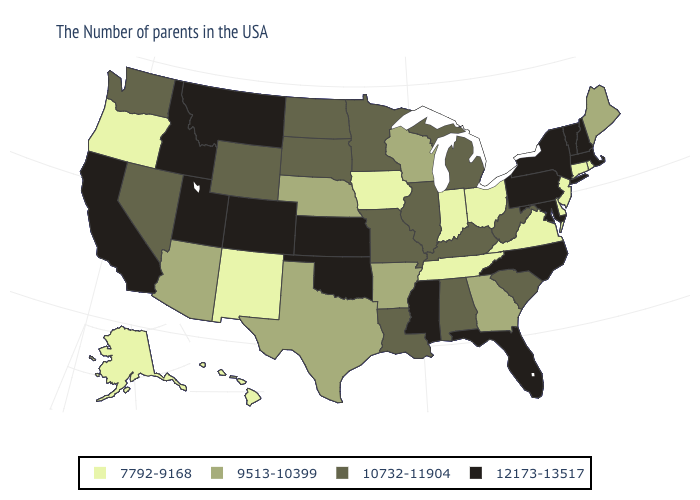What is the lowest value in states that border Oregon?
Answer briefly. 10732-11904. What is the value of Arizona?
Answer briefly. 9513-10399. Is the legend a continuous bar?
Keep it brief. No. Does Washington have the same value as Alaska?
Be succinct. No. Name the states that have a value in the range 10732-11904?
Short answer required. South Carolina, West Virginia, Michigan, Kentucky, Alabama, Illinois, Louisiana, Missouri, Minnesota, South Dakota, North Dakota, Wyoming, Nevada, Washington. Among the states that border New Mexico , does Utah have the highest value?
Write a very short answer. Yes. Name the states that have a value in the range 9513-10399?
Be succinct. Maine, Georgia, Wisconsin, Arkansas, Nebraska, Texas, Arizona. What is the value of Mississippi?
Quick response, please. 12173-13517. Name the states that have a value in the range 9513-10399?
Quick response, please. Maine, Georgia, Wisconsin, Arkansas, Nebraska, Texas, Arizona. Does New Hampshire have the same value as North Dakota?
Quick response, please. No. Name the states that have a value in the range 9513-10399?
Concise answer only. Maine, Georgia, Wisconsin, Arkansas, Nebraska, Texas, Arizona. What is the value of Massachusetts?
Keep it brief. 12173-13517. Which states hav the highest value in the MidWest?
Concise answer only. Kansas. What is the value of Oklahoma?
Short answer required. 12173-13517. 